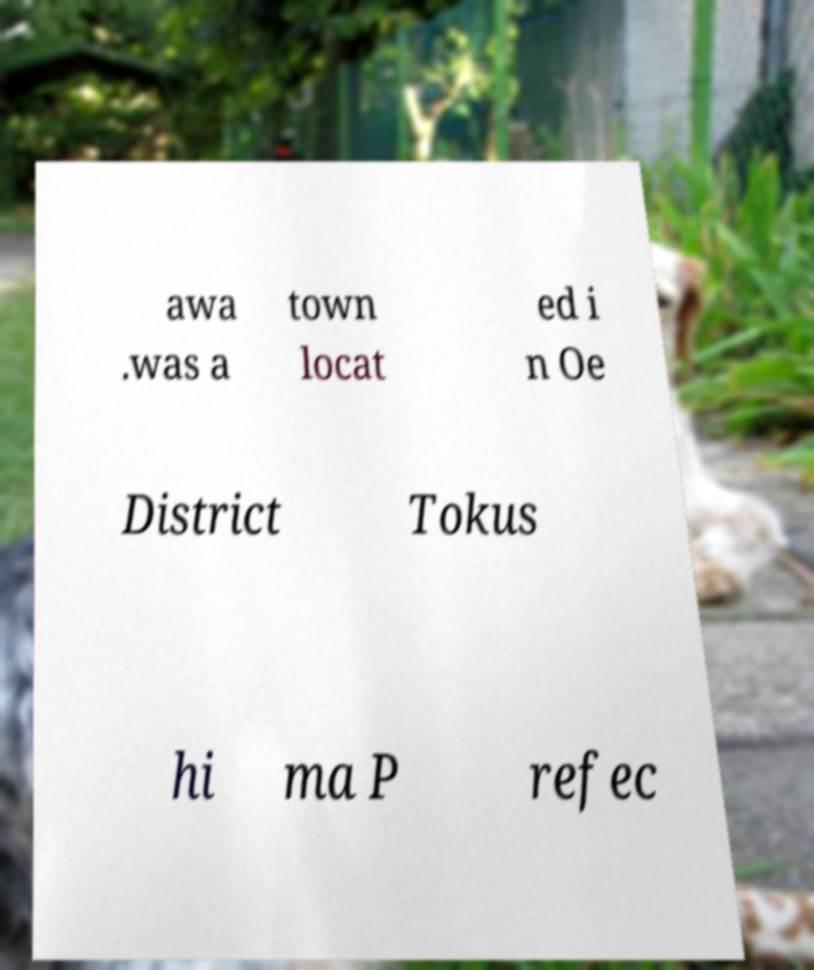Can you accurately transcribe the text from the provided image for me? awa .was a town locat ed i n Oe District Tokus hi ma P refec 